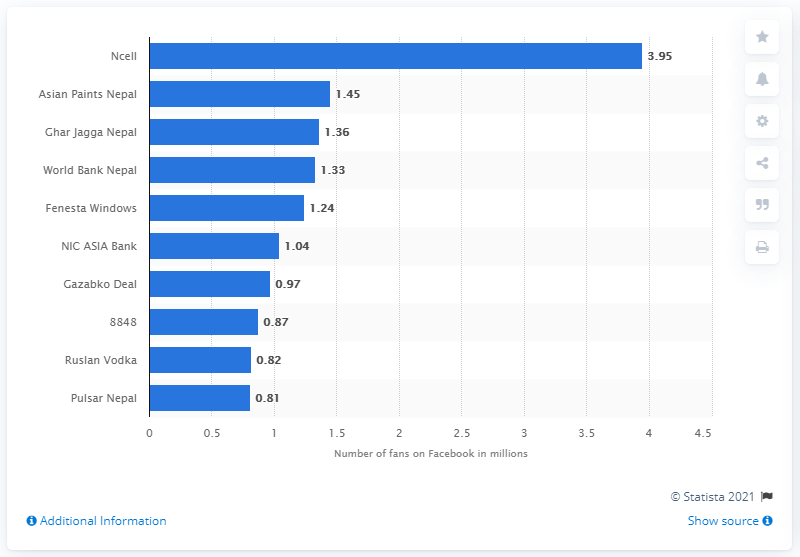Indicate a few pertinent items in this graphic. As of October 2020, Pulsar Nepal had 0.81 Facebook fans. Ncell was the brand in Nepal with the highest number of Facebook fans. 